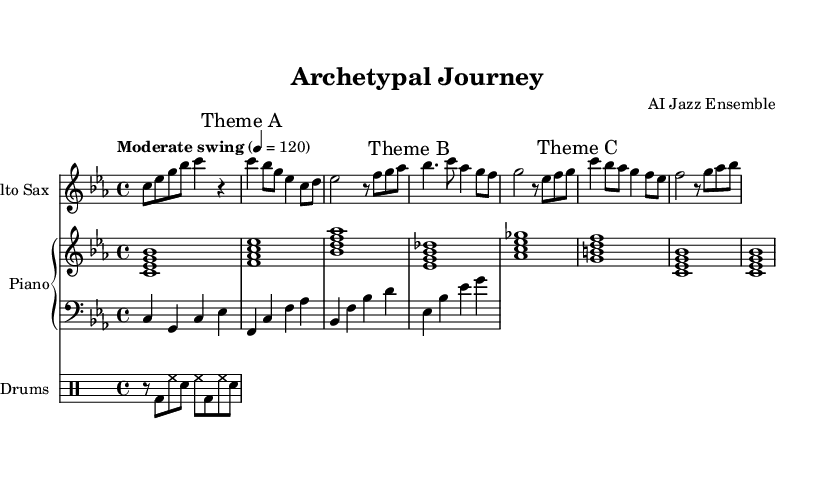What is the key signature of this music? The key signature is C minor, which has three flats (B, E, and A). You can identify this by looking at the key signature at the beginning of the staff.
Answer: C minor What is the time signature of this music? The time signature is 4/4, indicated at the beginning of the piece. In 4/4, there are four beats in each measure.
Answer: 4/4 What is the tempo marking for the piece? The tempo marking is "Moderate swing," followed by a tempo indication of 4 = 120. This means the piece should be played at a moderate swing feel with a beat equating to 120 beats per minute.
Answer: Moderate swing How many themes are indicated in the music? There are three themes indicated, marked as Theme A, Theme B, and Theme C throughout the sheet music. Each theme introduces a distinct melodic idea.
Answer: 3 What type of saxophone is notated in the score? The score indicates that the instrument is an Alto Sax, as specified at the beginning of the staff for the saxophone part.
Answer: Alto Sax Which chord is played during Theme A? The chord played during Theme A is C minor 7, indicated by the chord symbols written above the respective measures.
Answer: C minor 7 What rhythmic pattern is specified in the drum part? The drum part consists of a basic groove that alternates between a bass drum, hi-hat, and snare, which creates a swing feel appropriate for jazz. The specific pattern is identified through the notation in the drum staff.
Answer: Swing groove 